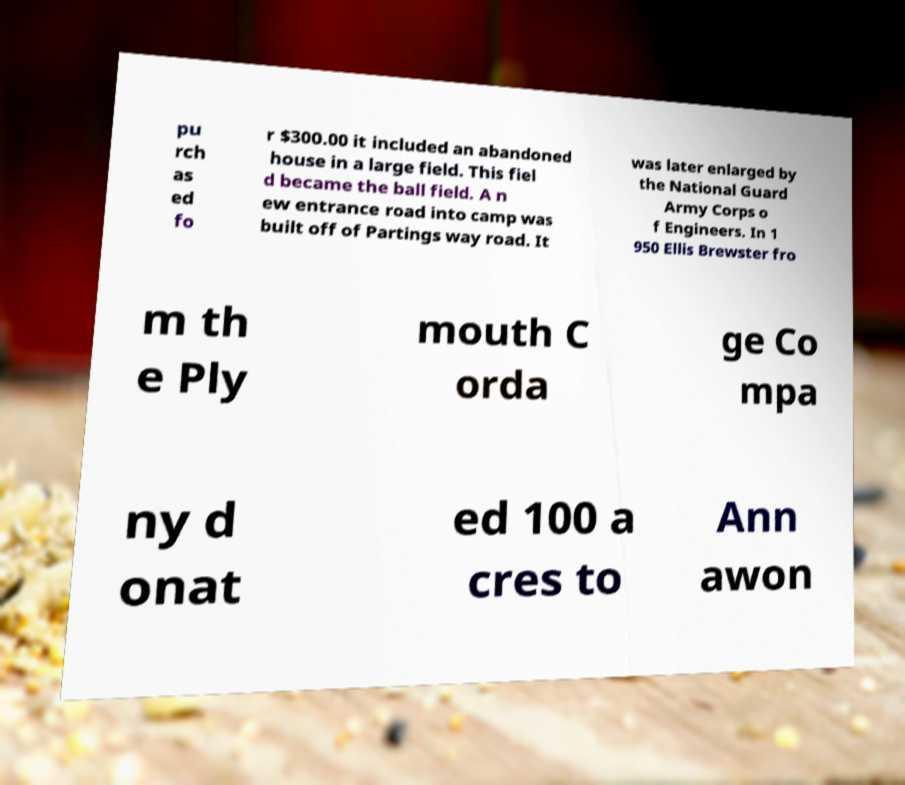Could you extract and type out the text from this image? pu rch as ed fo r $300.00 it included an abandoned house in a large field. This fiel d became the ball field. A n ew entrance road into camp was built off of Partings way road. It was later enlarged by the National Guard Army Corps o f Engineers. In 1 950 Ellis Brewster fro m th e Ply mouth C orda ge Co mpa ny d onat ed 100 a cres to Ann awon 